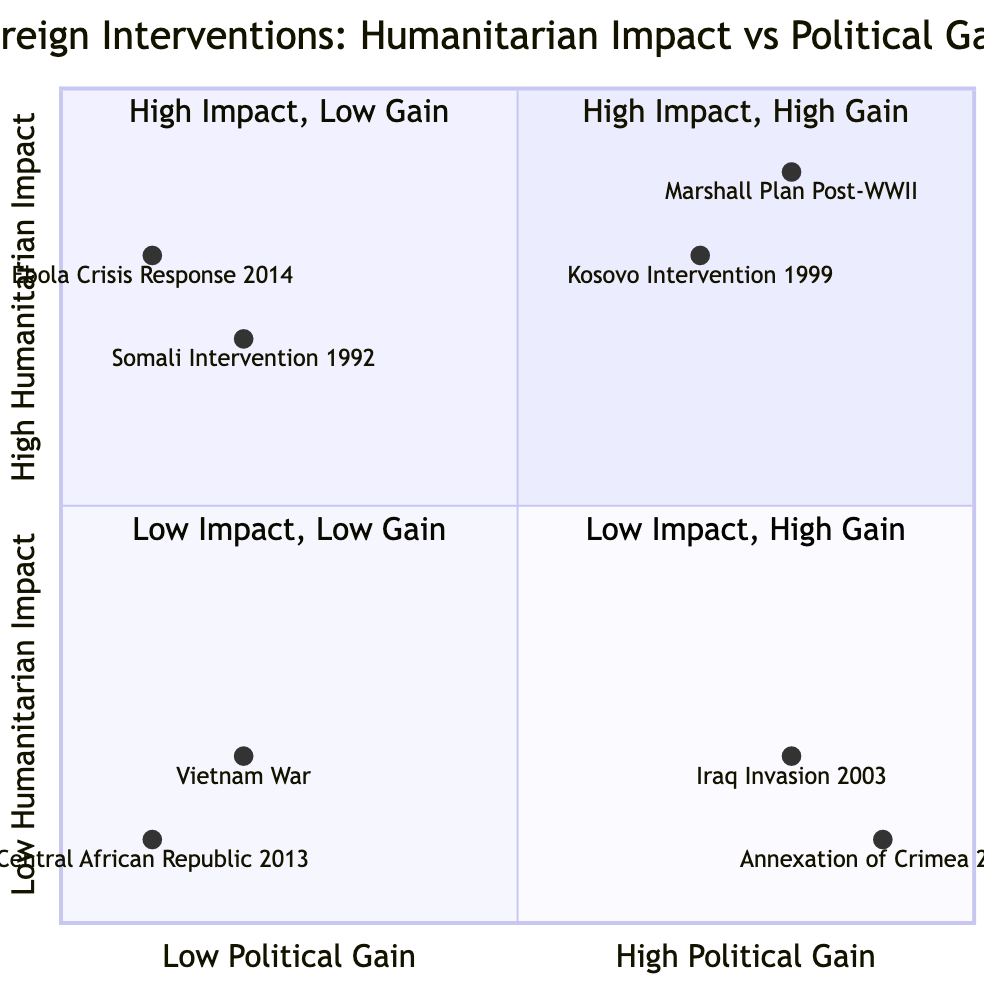What interventions are categorized under High Humanitarian Impact, High Political Gain? The quadrant for High Humanitarian Impact and High Political Gain includes Marshall Plan Post-WWII and Kosovo Intervention 1999. These are the two interventions that fit both criteria simultaneously.
Answer: Marshall Plan Post-WWII, Kosovo Intervention 1999 How many interventions have a Low Humanitarian Impact and Low Political Gain? There are two interventions listed in the Low Humanitarian Impact and Low Political Gain quadrant: Vietnam War and Intervention in Central African Republic 2013. Therefore, the total number of interventions in this category is two.
Answer: 2 Which intervention has the highest Political Gain? Examining the entries in the Low Impact, High Gain quadrant, the Annexation of Crimea 2014 has a coordinate (0.9, 0.1) showing it has the highest level of Political Gain among the listed interventions.
Answer: Annexation of Crimea 2014 What is the Political Gain of the Somali Intervention 1992? The Somali Intervention 1992 falls into the High Humanitarian Impact, Low Political Gain quadrant, represented by the coordinate (0.2, 0.7). Focusing on the x-axis value, which indicates Political Gain, it shows the value is 0.2.
Answer: 0.2 Which intervention provided a Low Humanitarian Impact but resulted in High Political Gain? In the quadrant specifically for Low Humanitarian Impact and High Political Gain, there are two interventions: Iraq Invasion 2003 and Annexation of Crimea 2014. The question asks specifically for one example; any of these will satisfy that requirement.
Answer: Iraq Invasion 2003 What is the Humanitarian Impact of the Ebola Crisis Response in West Africa 2014? The Ebola Crisis Response in West Africa 2014 is located in the High Humanitarian Impact, Low Political Gain quadrant at the coordinate (0.1, 0.8). Thus, its Humanitarian Impact, represented by the y-axis value, is 0.8.
Answer: 0.8 What do the quadrants suggest about the relationship between Humanitarian Impact and Political Gain? Analyzing the four quadrants indicates that interventions can have varied combinations of Humanitarian Impact and Political Gain. Interventions in the High Impact and High Gain quadrant demonstrate that effective humanitarian efforts can coincide with political interests, while interventions that yield Low Impact and Low Gain suggest a lack of strategic benefit and effectiveness.
Answer: Varied combinations How many total interventions are there in the chart? Counting across all four quadrants, we find a total of eight interventions listed as data points. This includes all those mentioned in the respective quadrants.
Answer: 8 